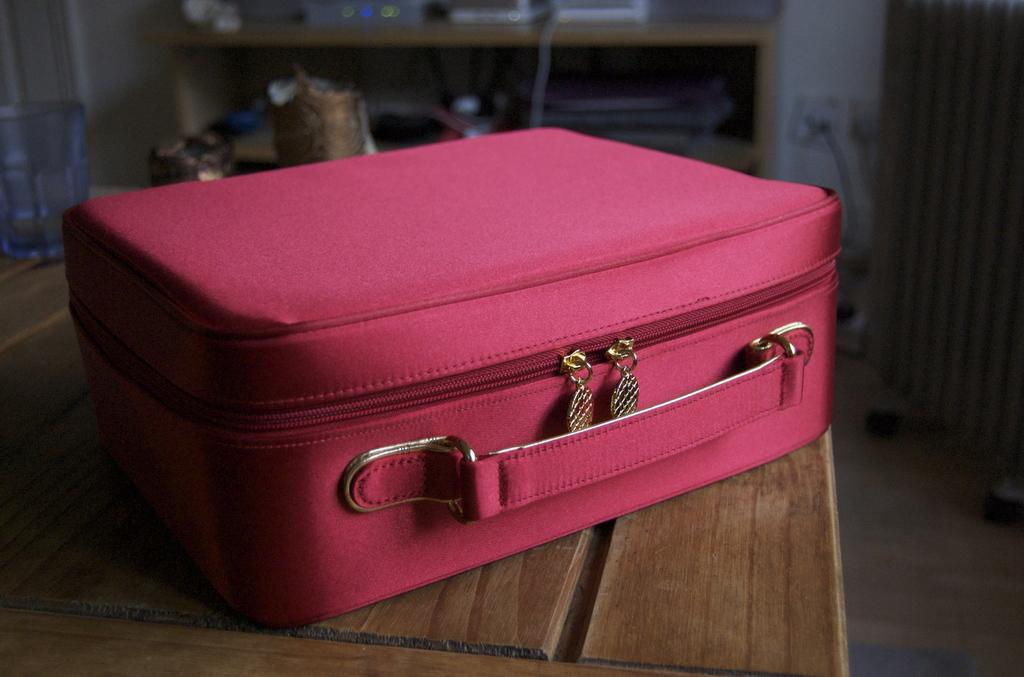What object can be seen in the image? There is a briefcase in the image. Where is the briefcase located? The briefcase is placed on a table. What type of tree is growing out of the briefcase in the image? There is no tree growing out of the briefcase in the image; it only contains a briefcase placed on a table. 